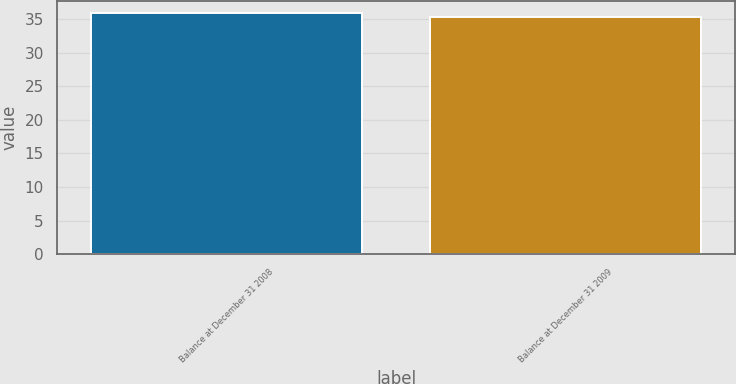Convert chart. <chart><loc_0><loc_0><loc_500><loc_500><bar_chart><fcel>Balance at December 31 2008<fcel>Balance at December 31 2009<nl><fcel>35.86<fcel>35.27<nl></chart> 